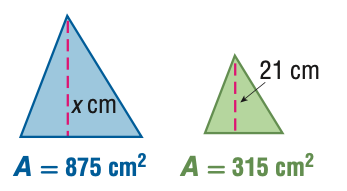Answer the mathemtical geometry problem and directly provide the correct option letter.
Question: For the pair of similar figures, use the given areas to find the scale factor from the blue to the green figure.
Choices: A: \frac { 9 } { 25 } B: \frac { 3 } { 5 } C: \frac { 5 } { 3 } D: \frac { 25 } { 9 } C 